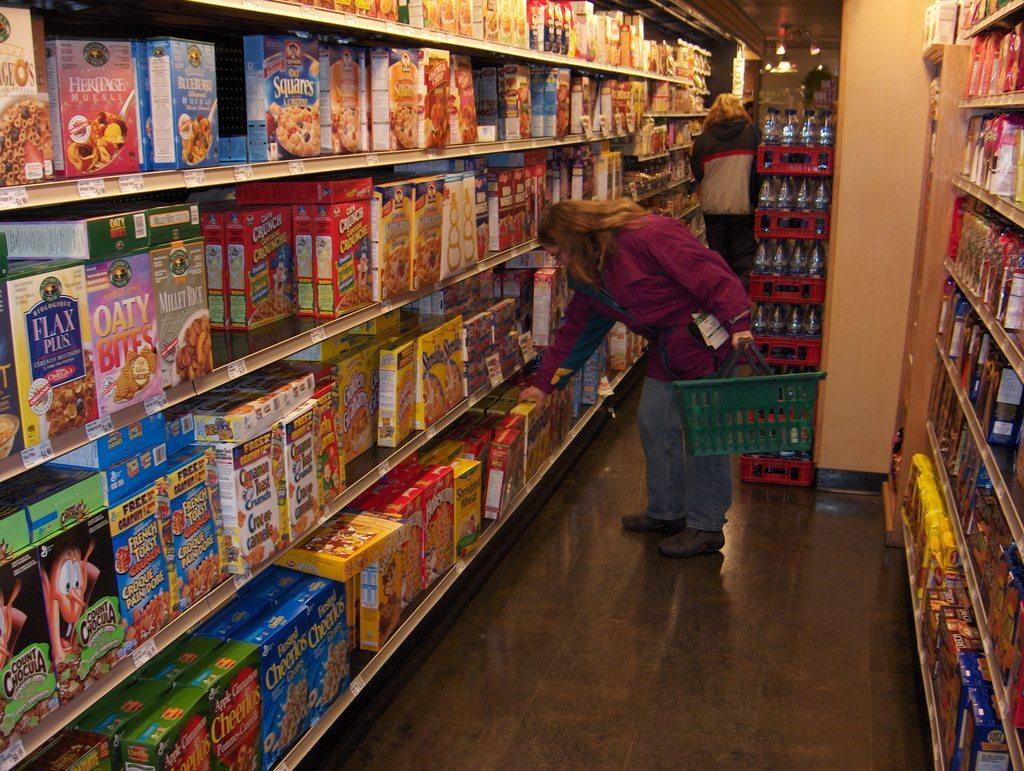<image>
Share a concise interpretation of the image provided. A woman examines cereal, one box of which is called Oaty Bites. 